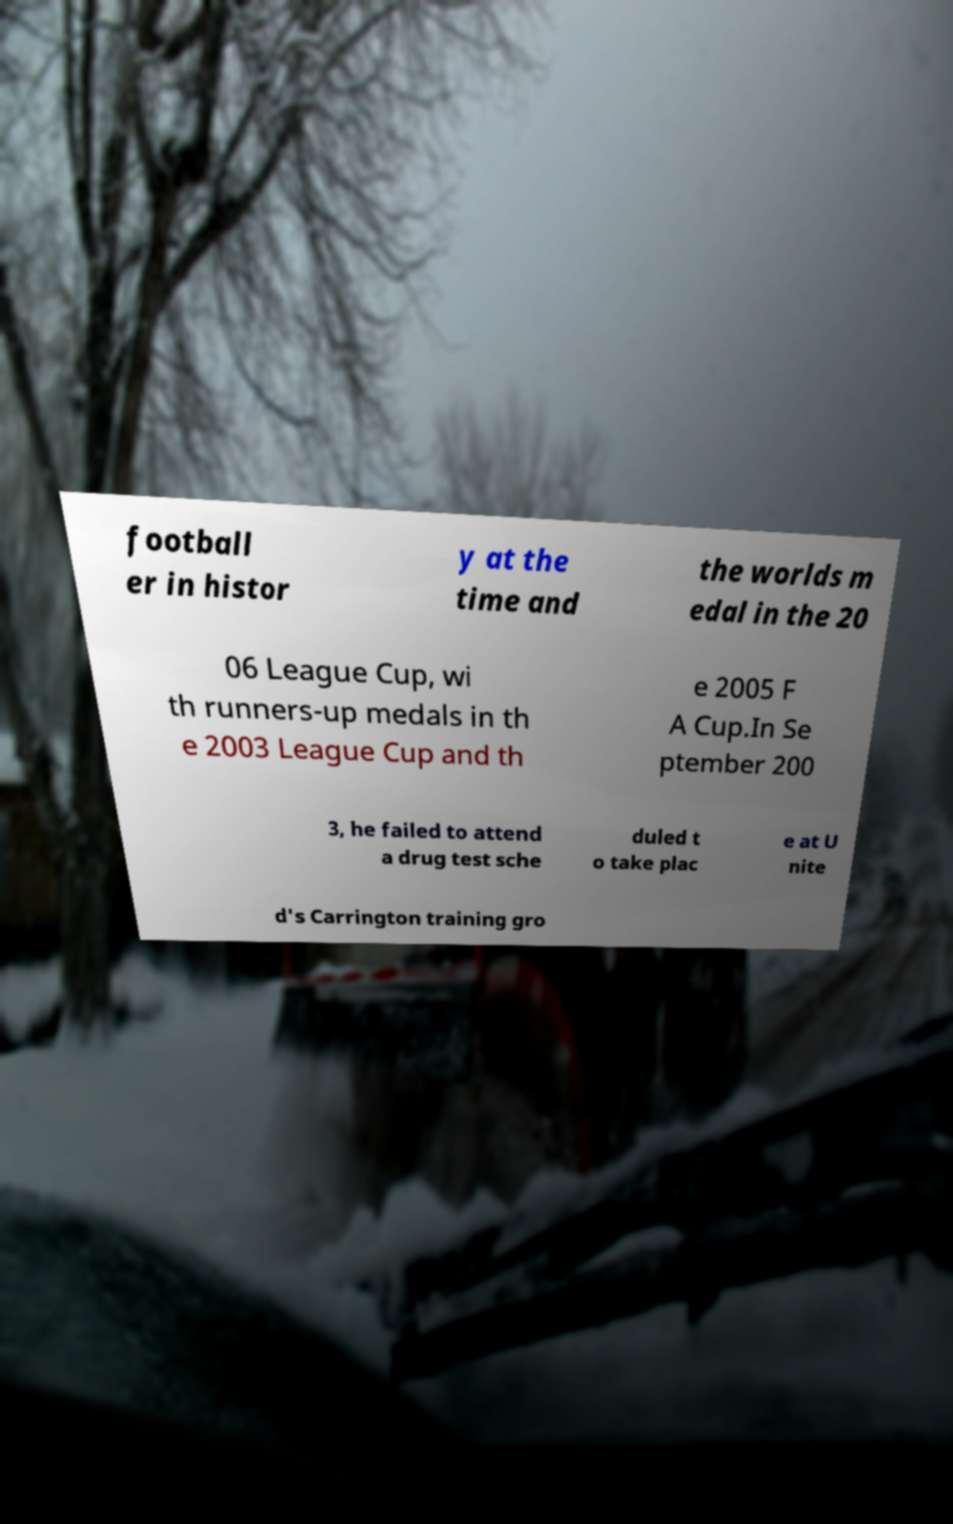Could you assist in decoding the text presented in this image and type it out clearly? football er in histor y at the time and the worlds m edal in the 20 06 League Cup, wi th runners-up medals in th e 2003 League Cup and th e 2005 F A Cup.In Se ptember 200 3, he failed to attend a drug test sche duled t o take plac e at U nite d's Carrington training gro 